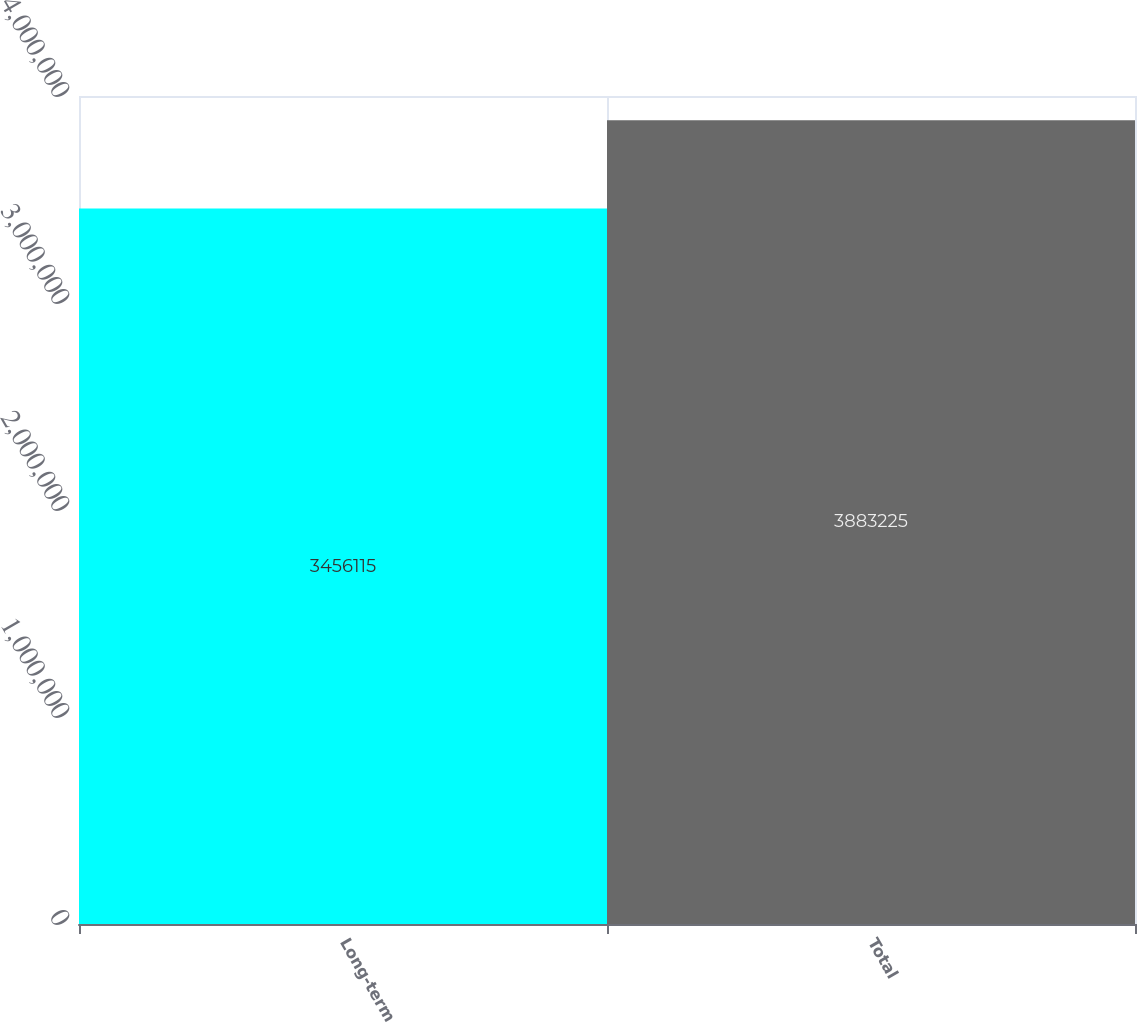Convert chart. <chart><loc_0><loc_0><loc_500><loc_500><bar_chart><fcel>Long-term<fcel>Total<nl><fcel>3.45612e+06<fcel>3.88322e+06<nl></chart> 